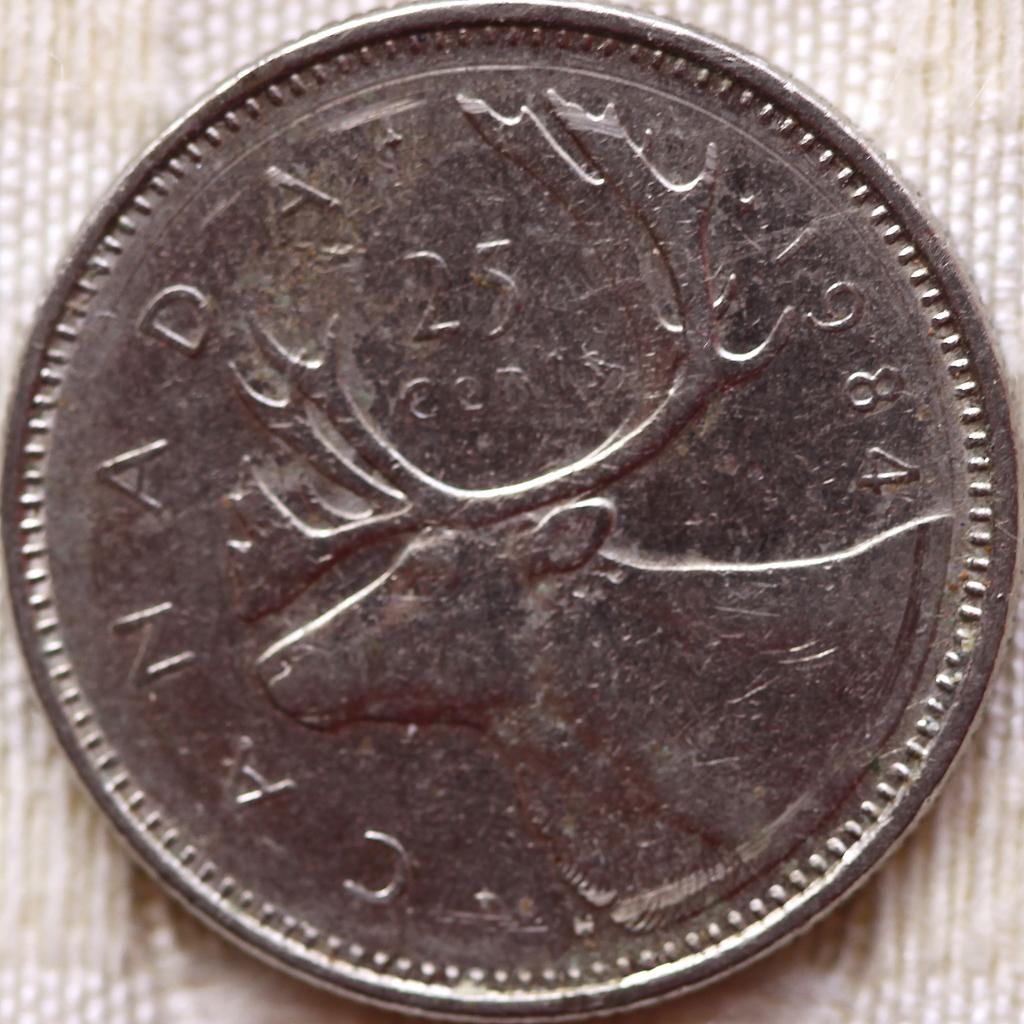<image>
Give a short and clear explanation of the subsequent image. A silver coin from Canada with a moose on it. 